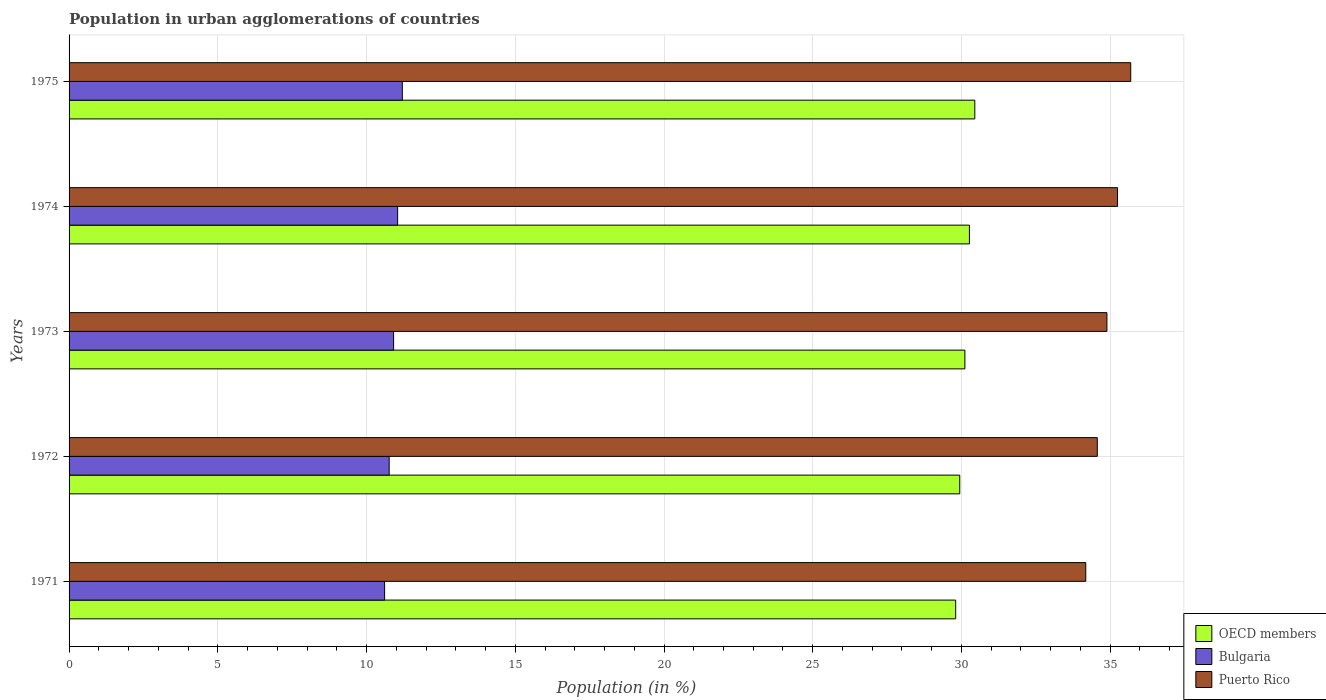How many different coloured bars are there?
Your answer should be compact. 3. How many groups of bars are there?
Your response must be concise. 5. Are the number of bars on each tick of the Y-axis equal?
Provide a succinct answer. Yes. How many bars are there on the 4th tick from the top?
Your answer should be compact. 3. What is the label of the 2nd group of bars from the top?
Your answer should be compact. 1974. In how many cases, is the number of bars for a given year not equal to the number of legend labels?
Your answer should be very brief. 0. What is the percentage of population in urban agglomerations in Bulgaria in 1975?
Ensure brevity in your answer.  11.2. Across all years, what is the maximum percentage of population in urban agglomerations in Puerto Rico?
Make the answer very short. 35.69. Across all years, what is the minimum percentage of population in urban agglomerations in OECD members?
Your response must be concise. 29.81. In which year was the percentage of population in urban agglomerations in Bulgaria maximum?
Your response must be concise. 1975. In which year was the percentage of population in urban agglomerations in Puerto Rico minimum?
Give a very brief answer. 1971. What is the total percentage of population in urban agglomerations in Puerto Rico in the graph?
Offer a terse response. 174.57. What is the difference between the percentage of population in urban agglomerations in Bulgaria in 1973 and that in 1974?
Your answer should be compact. -0.14. What is the difference between the percentage of population in urban agglomerations in Bulgaria in 1971 and the percentage of population in urban agglomerations in OECD members in 1974?
Provide a short and direct response. -19.66. What is the average percentage of population in urban agglomerations in Puerto Rico per year?
Offer a terse response. 34.91. In the year 1974, what is the difference between the percentage of population in urban agglomerations in Bulgaria and percentage of population in urban agglomerations in OECD members?
Offer a terse response. -19.22. What is the ratio of the percentage of population in urban agglomerations in OECD members in 1971 to that in 1975?
Your answer should be very brief. 0.98. Is the percentage of population in urban agglomerations in Puerto Rico in 1971 less than that in 1972?
Make the answer very short. Yes. Is the difference between the percentage of population in urban agglomerations in Bulgaria in 1974 and 1975 greater than the difference between the percentage of population in urban agglomerations in OECD members in 1974 and 1975?
Make the answer very short. Yes. What is the difference between the highest and the second highest percentage of population in urban agglomerations in Bulgaria?
Make the answer very short. 0.16. What is the difference between the highest and the lowest percentage of population in urban agglomerations in Bulgaria?
Offer a terse response. 0.6. Is the sum of the percentage of population in urban agglomerations in Puerto Rico in 1971 and 1973 greater than the maximum percentage of population in urban agglomerations in Bulgaria across all years?
Provide a succinct answer. Yes. Is it the case that in every year, the sum of the percentage of population in urban agglomerations in OECD members and percentage of population in urban agglomerations in Puerto Rico is greater than the percentage of population in urban agglomerations in Bulgaria?
Make the answer very short. Yes. How many bars are there?
Your response must be concise. 15. Are the values on the major ticks of X-axis written in scientific E-notation?
Ensure brevity in your answer.  No. Where does the legend appear in the graph?
Give a very brief answer. Bottom right. How are the legend labels stacked?
Your response must be concise. Vertical. What is the title of the graph?
Provide a short and direct response. Population in urban agglomerations of countries. What is the Population (in %) of OECD members in 1971?
Your answer should be very brief. 29.81. What is the Population (in %) in Bulgaria in 1971?
Your answer should be very brief. 10.61. What is the Population (in %) of Puerto Rico in 1971?
Your answer should be very brief. 34.18. What is the Population (in %) in OECD members in 1972?
Your response must be concise. 29.94. What is the Population (in %) of Bulgaria in 1972?
Keep it short and to the point. 10.76. What is the Population (in %) in Puerto Rico in 1972?
Ensure brevity in your answer.  34.57. What is the Population (in %) of OECD members in 1973?
Keep it short and to the point. 30.12. What is the Population (in %) in Bulgaria in 1973?
Offer a terse response. 10.91. What is the Population (in %) of Puerto Rico in 1973?
Your answer should be compact. 34.89. What is the Population (in %) of OECD members in 1974?
Keep it short and to the point. 30.27. What is the Population (in %) of Bulgaria in 1974?
Your answer should be very brief. 11.05. What is the Population (in %) of Puerto Rico in 1974?
Keep it short and to the point. 35.25. What is the Population (in %) in OECD members in 1975?
Ensure brevity in your answer.  30.45. What is the Population (in %) in Bulgaria in 1975?
Ensure brevity in your answer.  11.2. What is the Population (in %) of Puerto Rico in 1975?
Make the answer very short. 35.69. Across all years, what is the maximum Population (in %) in OECD members?
Your answer should be very brief. 30.45. Across all years, what is the maximum Population (in %) of Bulgaria?
Ensure brevity in your answer.  11.2. Across all years, what is the maximum Population (in %) in Puerto Rico?
Your response must be concise. 35.69. Across all years, what is the minimum Population (in %) of OECD members?
Offer a very short reply. 29.81. Across all years, what is the minimum Population (in %) in Bulgaria?
Your answer should be very brief. 10.61. Across all years, what is the minimum Population (in %) in Puerto Rico?
Keep it short and to the point. 34.18. What is the total Population (in %) in OECD members in the graph?
Provide a short and direct response. 150.58. What is the total Population (in %) of Bulgaria in the graph?
Offer a very short reply. 54.53. What is the total Population (in %) of Puerto Rico in the graph?
Ensure brevity in your answer.  174.57. What is the difference between the Population (in %) in OECD members in 1971 and that in 1972?
Offer a terse response. -0.14. What is the difference between the Population (in %) in Bulgaria in 1971 and that in 1972?
Your answer should be very brief. -0.15. What is the difference between the Population (in %) of Puerto Rico in 1971 and that in 1972?
Offer a terse response. -0.39. What is the difference between the Population (in %) of OECD members in 1971 and that in 1973?
Offer a very short reply. -0.31. What is the difference between the Population (in %) in Bulgaria in 1971 and that in 1973?
Provide a short and direct response. -0.3. What is the difference between the Population (in %) in Puerto Rico in 1971 and that in 1973?
Your response must be concise. -0.71. What is the difference between the Population (in %) of OECD members in 1971 and that in 1974?
Offer a terse response. -0.46. What is the difference between the Population (in %) of Bulgaria in 1971 and that in 1974?
Provide a short and direct response. -0.44. What is the difference between the Population (in %) in Puerto Rico in 1971 and that in 1974?
Offer a very short reply. -1.07. What is the difference between the Population (in %) of OECD members in 1971 and that in 1975?
Provide a short and direct response. -0.64. What is the difference between the Population (in %) in Bulgaria in 1971 and that in 1975?
Provide a short and direct response. -0.6. What is the difference between the Population (in %) of Puerto Rico in 1971 and that in 1975?
Your answer should be very brief. -1.51. What is the difference between the Population (in %) in OECD members in 1972 and that in 1973?
Make the answer very short. -0.17. What is the difference between the Population (in %) in Bulgaria in 1972 and that in 1973?
Offer a terse response. -0.15. What is the difference between the Population (in %) of Puerto Rico in 1972 and that in 1973?
Your answer should be very brief. -0.32. What is the difference between the Population (in %) of OECD members in 1972 and that in 1974?
Offer a terse response. -0.33. What is the difference between the Population (in %) of Bulgaria in 1972 and that in 1974?
Your answer should be very brief. -0.28. What is the difference between the Population (in %) in Puerto Rico in 1972 and that in 1974?
Your answer should be compact. -0.68. What is the difference between the Population (in %) of OECD members in 1972 and that in 1975?
Offer a very short reply. -0.51. What is the difference between the Population (in %) in Bulgaria in 1972 and that in 1975?
Ensure brevity in your answer.  -0.44. What is the difference between the Population (in %) of Puerto Rico in 1972 and that in 1975?
Offer a terse response. -1.12. What is the difference between the Population (in %) in OECD members in 1973 and that in 1974?
Offer a very short reply. -0.15. What is the difference between the Population (in %) in Bulgaria in 1973 and that in 1974?
Provide a succinct answer. -0.14. What is the difference between the Population (in %) in Puerto Rico in 1973 and that in 1974?
Your answer should be compact. -0.36. What is the difference between the Population (in %) of OECD members in 1973 and that in 1975?
Your answer should be compact. -0.33. What is the difference between the Population (in %) of Bulgaria in 1973 and that in 1975?
Your answer should be very brief. -0.29. What is the difference between the Population (in %) of Puerto Rico in 1973 and that in 1975?
Provide a succinct answer. -0.8. What is the difference between the Population (in %) of OECD members in 1974 and that in 1975?
Give a very brief answer. -0.18. What is the difference between the Population (in %) of Bulgaria in 1974 and that in 1975?
Provide a short and direct response. -0.16. What is the difference between the Population (in %) in Puerto Rico in 1974 and that in 1975?
Your answer should be very brief. -0.44. What is the difference between the Population (in %) of OECD members in 1971 and the Population (in %) of Bulgaria in 1972?
Ensure brevity in your answer.  19.04. What is the difference between the Population (in %) in OECD members in 1971 and the Population (in %) in Puerto Rico in 1972?
Make the answer very short. -4.76. What is the difference between the Population (in %) in Bulgaria in 1971 and the Population (in %) in Puerto Rico in 1972?
Provide a succinct answer. -23.96. What is the difference between the Population (in %) in OECD members in 1971 and the Population (in %) in Bulgaria in 1973?
Keep it short and to the point. 18.9. What is the difference between the Population (in %) in OECD members in 1971 and the Population (in %) in Puerto Rico in 1973?
Provide a succinct answer. -5.08. What is the difference between the Population (in %) of Bulgaria in 1971 and the Population (in %) of Puerto Rico in 1973?
Your answer should be very brief. -24.28. What is the difference between the Population (in %) in OECD members in 1971 and the Population (in %) in Bulgaria in 1974?
Make the answer very short. 18.76. What is the difference between the Population (in %) in OECD members in 1971 and the Population (in %) in Puerto Rico in 1974?
Your response must be concise. -5.44. What is the difference between the Population (in %) in Bulgaria in 1971 and the Population (in %) in Puerto Rico in 1974?
Your answer should be compact. -24.64. What is the difference between the Population (in %) of OECD members in 1971 and the Population (in %) of Bulgaria in 1975?
Make the answer very short. 18.6. What is the difference between the Population (in %) of OECD members in 1971 and the Population (in %) of Puerto Rico in 1975?
Your response must be concise. -5.88. What is the difference between the Population (in %) of Bulgaria in 1971 and the Population (in %) of Puerto Rico in 1975?
Give a very brief answer. -25.08. What is the difference between the Population (in %) in OECD members in 1972 and the Population (in %) in Bulgaria in 1973?
Provide a succinct answer. 19.03. What is the difference between the Population (in %) in OECD members in 1972 and the Population (in %) in Puerto Rico in 1973?
Provide a short and direct response. -4.95. What is the difference between the Population (in %) of Bulgaria in 1972 and the Population (in %) of Puerto Rico in 1973?
Give a very brief answer. -24.13. What is the difference between the Population (in %) in OECD members in 1972 and the Population (in %) in Bulgaria in 1974?
Offer a very short reply. 18.9. What is the difference between the Population (in %) in OECD members in 1972 and the Population (in %) in Puerto Rico in 1974?
Provide a short and direct response. -5.3. What is the difference between the Population (in %) in Bulgaria in 1972 and the Population (in %) in Puerto Rico in 1974?
Provide a succinct answer. -24.49. What is the difference between the Population (in %) of OECD members in 1972 and the Population (in %) of Bulgaria in 1975?
Your response must be concise. 18.74. What is the difference between the Population (in %) of OECD members in 1972 and the Population (in %) of Puerto Rico in 1975?
Your response must be concise. -5.75. What is the difference between the Population (in %) in Bulgaria in 1972 and the Population (in %) in Puerto Rico in 1975?
Ensure brevity in your answer.  -24.93. What is the difference between the Population (in %) of OECD members in 1973 and the Population (in %) of Bulgaria in 1974?
Your answer should be very brief. 19.07. What is the difference between the Population (in %) in OECD members in 1973 and the Population (in %) in Puerto Rico in 1974?
Offer a terse response. -5.13. What is the difference between the Population (in %) in Bulgaria in 1973 and the Population (in %) in Puerto Rico in 1974?
Provide a succinct answer. -24.34. What is the difference between the Population (in %) of OECD members in 1973 and the Population (in %) of Bulgaria in 1975?
Keep it short and to the point. 18.91. What is the difference between the Population (in %) of OECD members in 1973 and the Population (in %) of Puerto Rico in 1975?
Your answer should be compact. -5.58. What is the difference between the Population (in %) in Bulgaria in 1973 and the Population (in %) in Puerto Rico in 1975?
Your response must be concise. -24.78. What is the difference between the Population (in %) of OECD members in 1974 and the Population (in %) of Bulgaria in 1975?
Provide a succinct answer. 19.06. What is the difference between the Population (in %) in OECD members in 1974 and the Population (in %) in Puerto Rico in 1975?
Provide a short and direct response. -5.42. What is the difference between the Population (in %) in Bulgaria in 1974 and the Population (in %) in Puerto Rico in 1975?
Your answer should be compact. -24.65. What is the average Population (in %) in OECD members per year?
Provide a short and direct response. 30.12. What is the average Population (in %) of Bulgaria per year?
Offer a terse response. 10.91. What is the average Population (in %) in Puerto Rico per year?
Offer a terse response. 34.91. In the year 1971, what is the difference between the Population (in %) in OECD members and Population (in %) in Bulgaria?
Your answer should be compact. 19.2. In the year 1971, what is the difference between the Population (in %) of OECD members and Population (in %) of Puerto Rico?
Offer a very short reply. -4.37. In the year 1971, what is the difference between the Population (in %) of Bulgaria and Population (in %) of Puerto Rico?
Ensure brevity in your answer.  -23.57. In the year 1972, what is the difference between the Population (in %) in OECD members and Population (in %) in Bulgaria?
Provide a succinct answer. 19.18. In the year 1972, what is the difference between the Population (in %) of OECD members and Population (in %) of Puerto Rico?
Offer a terse response. -4.62. In the year 1972, what is the difference between the Population (in %) of Bulgaria and Population (in %) of Puerto Rico?
Your answer should be compact. -23.81. In the year 1973, what is the difference between the Population (in %) in OECD members and Population (in %) in Bulgaria?
Offer a terse response. 19.21. In the year 1973, what is the difference between the Population (in %) of OECD members and Population (in %) of Puerto Rico?
Offer a terse response. -4.77. In the year 1973, what is the difference between the Population (in %) in Bulgaria and Population (in %) in Puerto Rico?
Offer a terse response. -23.98. In the year 1974, what is the difference between the Population (in %) in OECD members and Population (in %) in Bulgaria?
Make the answer very short. 19.22. In the year 1974, what is the difference between the Population (in %) in OECD members and Population (in %) in Puerto Rico?
Make the answer very short. -4.98. In the year 1974, what is the difference between the Population (in %) in Bulgaria and Population (in %) in Puerto Rico?
Offer a very short reply. -24.2. In the year 1975, what is the difference between the Population (in %) of OECD members and Population (in %) of Bulgaria?
Keep it short and to the point. 19.25. In the year 1975, what is the difference between the Population (in %) of OECD members and Population (in %) of Puerto Rico?
Make the answer very short. -5.24. In the year 1975, what is the difference between the Population (in %) in Bulgaria and Population (in %) in Puerto Rico?
Provide a short and direct response. -24.49. What is the ratio of the Population (in %) in Bulgaria in 1971 to that in 1972?
Offer a very short reply. 0.99. What is the ratio of the Population (in %) in OECD members in 1971 to that in 1973?
Provide a short and direct response. 0.99. What is the ratio of the Population (in %) of Bulgaria in 1971 to that in 1973?
Your answer should be very brief. 0.97. What is the ratio of the Population (in %) in Puerto Rico in 1971 to that in 1973?
Make the answer very short. 0.98. What is the ratio of the Population (in %) of OECD members in 1971 to that in 1974?
Offer a terse response. 0.98. What is the ratio of the Population (in %) of Bulgaria in 1971 to that in 1974?
Provide a short and direct response. 0.96. What is the ratio of the Population (in %) in Puerto Rico in 1971 to that in 1974?
Your answer should be very brief. 0.97. What is the ratio of the Population (in %) of OECD members in 1971 to that in 1975?
Make the answer very short. 0.98. What is the ratio of the Population (in %) in Bulgaria in 1971 to that in 1975?
Your response must be concise. 0.95. What is the ratio of the Population (in %) of Puerto Rico in 1971 to that in 1975?
Offer a very short reply. 0.96. What is the ratio of the Population (in %) of OECD members in 1972 to that in 1973?
Your answer should be very brief. 0.99. What is the ratio of the Population (in %) in Bulgaria in 1972 to that in 1973?
Make the answer very short. 0.99. What is the ratio of the Population (in %) of Puerto Rico in 1972 to that in 1973?
Your response must be concise. 0.99. What is the ratio of the Population (in %) of OECD members in 1972 to that in 1974?
Your answer should be very brief. 0.99. What is the ratio of the Population (in %) in Bulgaria in 1972 to that in 1974?
Provide a short and direct response. 0.97. What is the ratio of the Population (in %) of Puerto Rico in 1972 to that in 1974?
Give a very brief answer. 0.98. What is the ratio of the Population (in %) in OECD members in 1972 to that in 1975?
Offer a terse response. 0.98. What is the ratio of the Population (in %) in Bulgaria in 1972 to that in 1975?
Keep it short and to the point. 0.96. What is the ratio of the Population (in %) of Puerto Rico in 1972 to that in 1975?
Provide a succinct answer. 0.97. What is the ratio of the Population (in %) in OECD members in 1973 to that in 1974?
Your answer should be very brief. 0.99. What is the ratio of the Population (in %) of Bulgaria in 1973 to that in 1975?
Offer a terse response. 0.97. What is the ratio of the Population (in %) in Puerto Rico in 1973 to that in 1975?
Ensure brevity in your answer.  0.98. What is the ratio of the Population (in %) in Bulgaria in 1974 to that in 1975?
Keep it short and to the point. 0.99. What is the ratio of the Population (in %) of Puerto Rico in 1974 to that in 1975?
Offer a very short reply. 0.99. What is the difference between the highest and the second highest Population (in %) of OECD members?
Give a very brief answer. 0.18. What is the difference between the highest and the second highest Population (in %) of Bulgaria?
Keep it short and to the point. 0.16. What is the difference between the highest and the second highest Population (in %) in Puerto Rico?
Keep it short and to the point. 0.44. What is the difference between the highest and the lowest Population (in %) of OECD members?
Provide a short and direct response. 0.64. What is the difference between the highest and the lowest Population (in %) in Bulgaria?
Provide a short and direct response. 0.6. What is the difference between the highest and the lowest Population (in %) in Puerto Rico?
Provide a succinct answer. 1.51. 